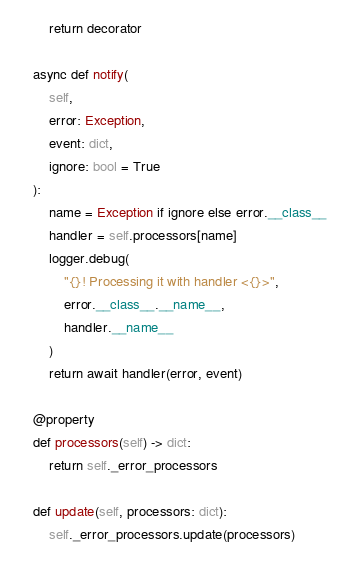<code> <loc_0><loc_0><loc_500><loc_500><_Python_>        return decorator

    async def notify(
        self,
        error: Exception,
        event: dict,
        ignore: bool = True
    ):
        name = Exception if ignore else error.__class__
        handler = self.processors[name]
        logger.debug(
            "{}! Processing it with handler <{}>",
            error.__class__.__name__,
            handler.__name__
        )
        return await handler(error, event)

    @property
    def processors(self) -> dict:
        return self._error_processors

    def update(self, processors: dict):
        self._error_processors.update(processors)</code> 